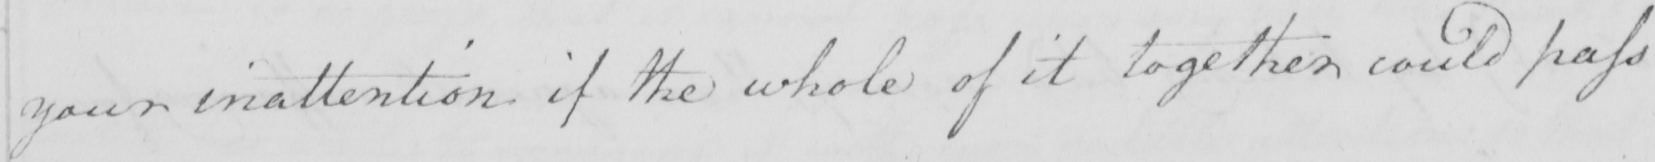What text is written in this handwritten line? your inattention if the whole of it together could pass 